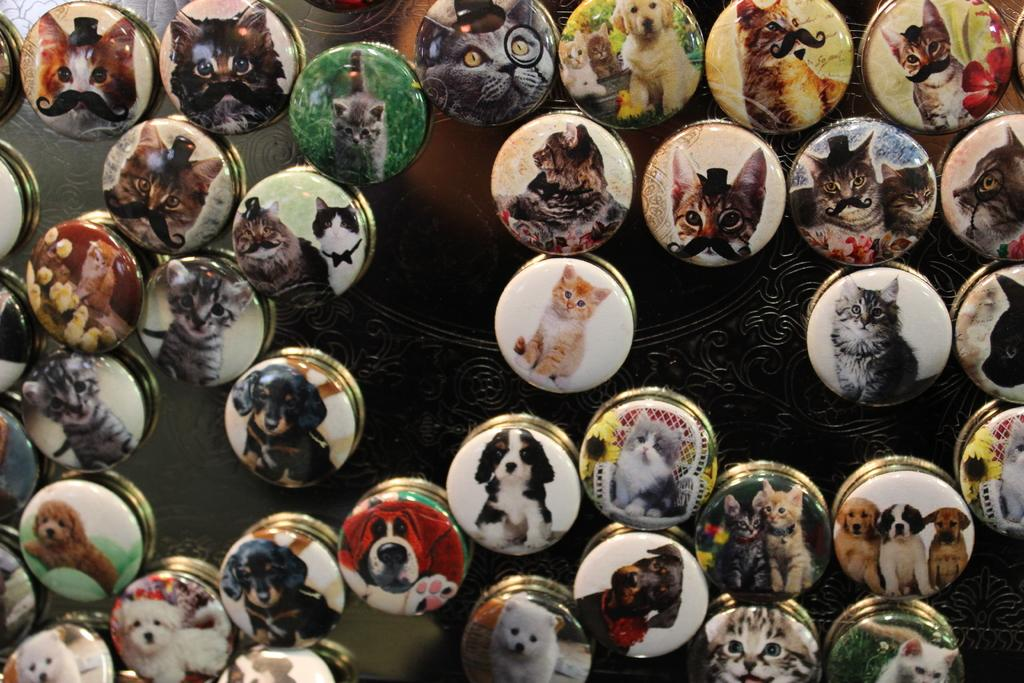What is present in the image? There are batches in the image. What distinguishes each batch from the others? Each batch has a different kind of animal image. What historical event is depicted in the image? There is no historical event depicted in the image; it features batches with different animal images. 